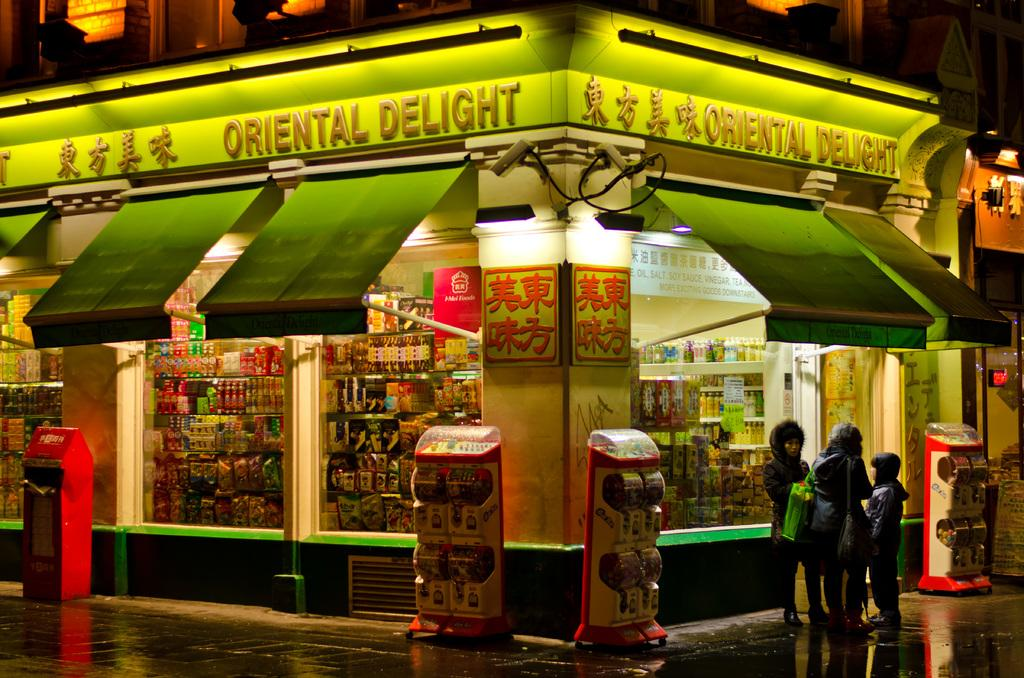<image>
Describe the image concisely. Store front on the corner that is called Oriental Delight. 